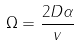<formula> <loc_0><loc_0><loc_500><loc_500>\Omega = \frac { 2 D \alpha } { v }</formula> 